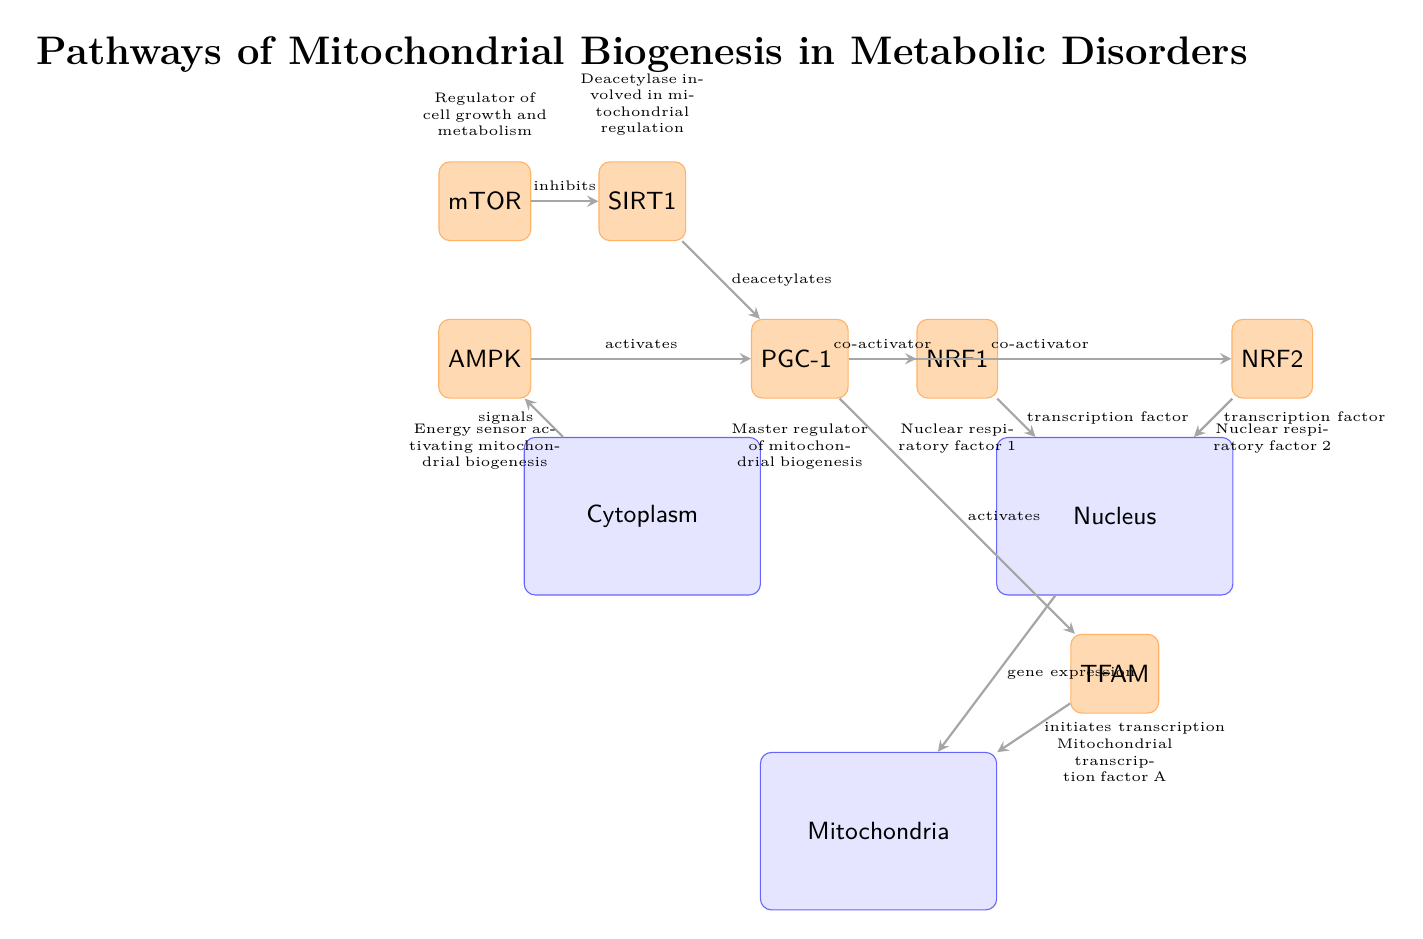What is the role of PGC-1α in mitochondrial biogenesis? PGC-1α acts as a master regulator that activates several downstream factors necessary for mitochondrial biogenesis, including TFAM.
Answer: Master regulator of mitochondrial biogenesis How many proteins are involved in signaling from the nucleus to the mitochondria? The diagram shows two proteins, NRF1 and NRF2, which both translocate to the nucleus and act as transcription factors to initiate gene expression in the mitochondria.
Answer: 2 Which protein is inhibited by mTOR? The diagram specifies that mTOR inhibits SIRT1, indicating that SIRT1's activity is negatively regulated by mTOR in relation to mitochondrial biogenesis.
Answer: SIRT1 What initiates transcription in the mitochondria? TFAM is indicated in the diagram as the protein that activates transcription within the mitochondrial compartment.
Answer: TFAM What type of interaction occurs between AMPK and PGC-1α? The diagram indicates that AMPK activates PGC-1α, establishing a direct relationship in the signaling pathway concerning energy sensing and mitochondrial biogenesis.
Answer: activates Explain how signals from the cytoplasm affect AMPK. Signals from the cytoplasm are depicted as a direct influence on AMPK, thus suggesting that changes outside the nucleus can activate AMPK and trigger the subsequent signaling pathway for mitochondrial biogenesis.
Answer: signals Which proteins act as transcription factors in this diagram? NRF1 and NRF2 are labeled in the diagram as transcription factors that play a critical role in mediating the genetic expression necessary for mitochondrial biogenesis.
Answer: NRF1, NRF2 What is the relationship between PGC-1α and TFAM? The diagram shows that PGC-1α activates TFAM, linking them in the signaling pathway related to mitochondrial transcription activation.
Answer: activates 